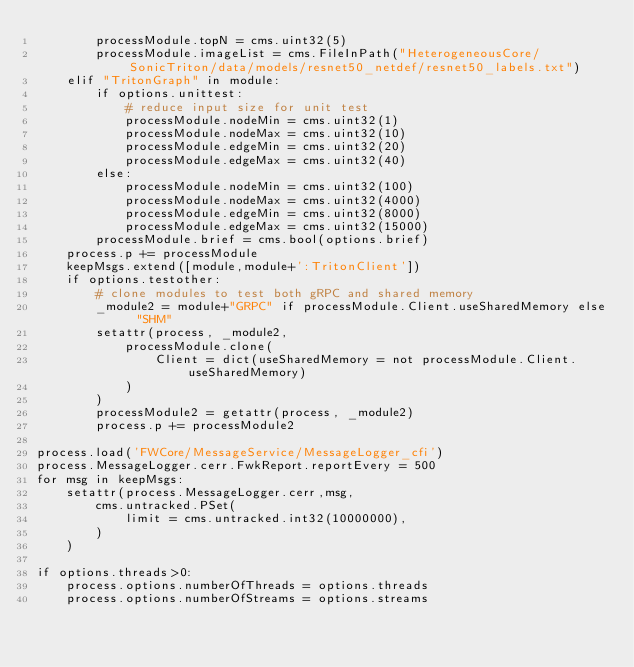Convert code to text. <code><loc_0><loc_0><loc_500><loc_500><_Python_>        processModule.topN = cms.uint32(5)
        processModule.imageList = cms.FileInPath("HeterogeneousCore/SonicTriton/data/models/resnet50_netdef/resnet50_labels.txt")
    elif "TritonGraph" in module:
        if options.unittest:
            # reduce input size for unit test
            processModule.nodeMin = cms.uint32(1)
            processModule.nodeMax = cms.uint32(10)
            processModule.edgeMin = cms.uint32(20)
            processModule.edgeMax = cms.uint32(40)
        else:
            processModule.nodeMin = cms.uint32(100)
            processModule.nodeMax = cms.uint32(4000)
            processModule.edgeMin = cms.uint32(8000)
            processModule.edgeMax = cms.uint32(15000)
        processModule.brief = cms.bool(options.brief)
    process.p += processModule
    keepMsgs.extend([module,module+':TritonClient'])
    if options.testother:
        # clone modules to test both gRPC and shared memory
        _module2 = module+"GRPC" if processModule.Client.useSharedMemory else "SHM"
        setattr(process, _module2,
            processModule.clone(
                Client = dict(useSharedMemory = not processModule.Client.useSharedMemory)
            )
        )
        processModule2 = getattr(process, _module2)
        process.p += processModule2

process.load('FWCore/MessageService/MessageLogger_cfi')
process.MessageLogger.cerr.FwkReport.reportEvery = 500
for msg in keepMsgs:
    setattr(process.MessageLogger.cerr,msg,
        cms.untracked.PSet(
            limit = cms.untracked.int32(10000000),
        )
    )

if options.threads>0:
    process.options.numberOfThreads = options.threads
    process.options.numberOfStreams = options.streams

</code> 